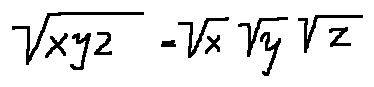<formula> <loc_0><loc_0><loc_500><loc_500>\sqrt { x y z } = \sqrt { x } \sqrt { y } \sqrt { z }</formula> 